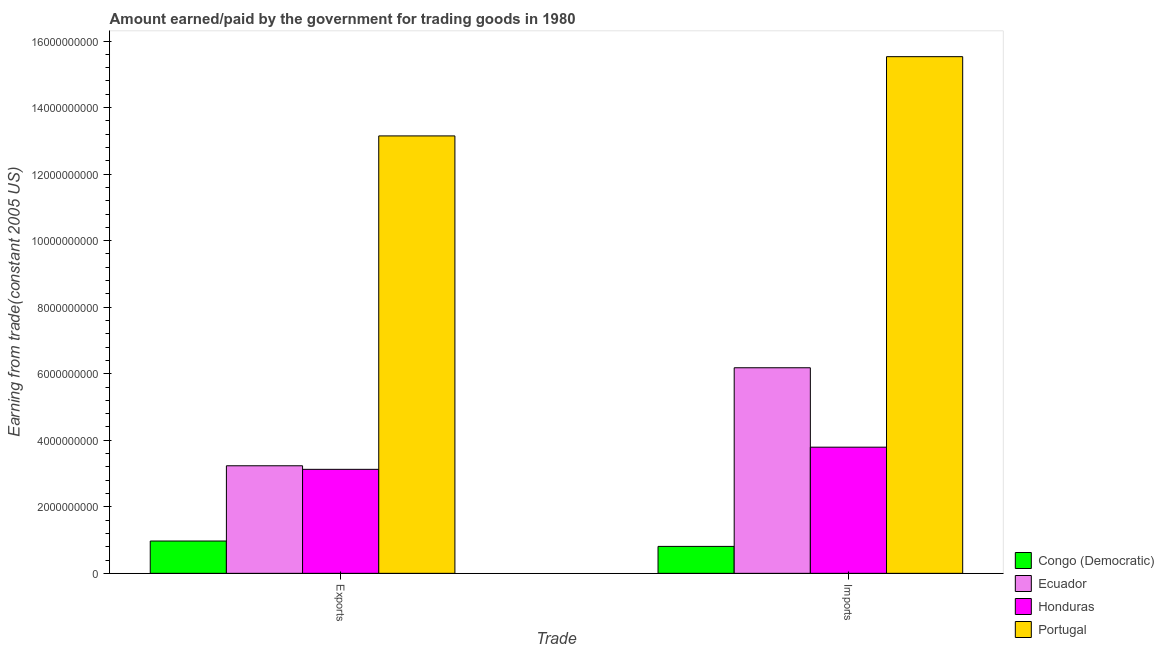How many groups of bars are there?
Offer a terse response. 2. Are the number of bars on each tick of the X-axis equal?
Offer a terse response. Yes. How many bars are there on the 2nd tick from the left?
Offer a very short reply. 4. How many bars are there on the 1st tick from the right?
Offer a terse response. 4. What is the label of the 2nd group of bars from the left?
Your response must be concise. Imports. What is the amount paid for imports in Honduras?
Give a very brief answer. 3.79e+09. Across all countries, what is the maximum amount earned from exports?
Make the answer very short. 1.31e+1. Across all countries, what is the minimum amount earned from exports?
Ensure brevity in your answer.  9.71e+08. In which country was the amount earned from exports minimum?
Your answer should be compact. Congo (Democratic). What is the total amount earned from exports in the graph?
Give a very brief answer. 2.05e+1. What is the difference between the amount paid for imports in Honduras and that in Congo (Democratic)?
Provide a short and direct response. 2.98e+09. What is the difference between the amount earned from exports in Portugal and the amount paid for imports in Honduras?
Provide a short and direct response. 9.36e+09. What is the average amount paid for imports per country?
Provide a succinct answer. 6.58e+09. What is the difference between the amount earned from exports and amount paid for imports in Honduras?
Provide a succinct answer. -6.66e+08. In how many countries, is the amount earned from exports greater than 2800000000 US$?
Your response must be concise. 3. What is the ratio of the amount earned from exports in Congo (Democratic) to that in Honduras?
Offer a very short reply. 0.31. What does the 4th bar from the left in Imports represents?
Offer a very short reply. Portugal. What does the 3rd bar from the right in Exports represents?
Give a very brief answer. Ecuador. Are the values on the major ticks of Y-axis written in scientific E-notation?
Your answer should be very brief. No. Does the graph contain any zero values?
Keep it short and to the point. No. Does the graph contain grids?
Provide a short and direct response. No. How many legend labels are there?
Provide a short and direct response. 4. How are the legend labels stacked?
Provide a short and direct response. Vertical. What is the title of the graph?
Make the answer very short. Amount earned/paid by the government for trading goods in 1980. Does "Jordan" appear as one of the legend labels in the graph?
Provide a short and direct response. No. What is the label or title of the X-axis?
Ensure brevity in your answer.  Trade. What is the label or title of the Y-axis?
Make the answer very short. Earning from trade(constant 2005 US). What is the Earning from trade(constant 2005 US) in Congo (Democratic) in Exports?
Your answer should be compact. 9.71e+08. What is the Earning from trade(constant 2005 US) of Ecuador in Exports?
Provide a short and direct response. 3.23e+09. What is the Earning from trade(constant 2005 US) of Honduras in Exports?
Provide a short and direct response. 3.13e+09. What is the Earning from trade(constant 2005 US) in Portugal in Exports?
Your response must be concise. 1.31e+1. What is the Earning from trade(constant 2005 US) in Congo (Democratic) in Imports?
Offer a terse response. 8.10e+08. What is the Earning from trade(constant 2005 US) of Ecuador in Imports?
Your answer should be very brief. 6.18e+09. What is the Earning from trade(constant 2005 US) in Honduras in Imports?
Offer a very short reply. 3.79e+09. What is the Earning from trade(constant 2005 US) of Portugal in Imports?
Make the answer very short. 1.55e+1. Across all Trade, what is the maximum Earning from trade(constant 2005 US) of Congo (Democratic)?
Give a very brief answer. 9.71e+08. Across all Trade, what is the maximum Earning from trade(constant 2005 US) in Ecuador?
Provide a succinct answer. 6.18e+09. Across all Trade, what is the maximum Earning from trade(constant 2005 US) in Honduras?
Offer a very short reply. 3.79e+09. Across all Trade, what is the maximum Earning from trade(constant 2005 US) of Portugal?
Make the answer very short. 1.55e+1. Across all Trade, what is the minimum Earning from trade(constant 2005 US) of Congo (Democratic)?
Provide a succinct answer. 8.10e+08. Across all Trade, what is the minimum Earning from trade(constant 2005 US) in Ecuador?
Offer a very short reply. 3.23e+09. Across all Trade, what is the minimum Earning from trade(constant 2005 US) in Honduras?
Make the answer very short. 3.13e+09. Across all Trade, what is the minimum Earning from trade(constant 2005 US) in Portugal?
Provide a short and direct response. 1.31e+1. What is the total Earning from trade(constant 2005 US) in Congo (Democratic) in the graph?
Keep it short and to the point. 1.78e+09. What is the total Earning from trade(constant 2005 US) in Ecuador in the graph?
Provide a succinct answer. 9.41e+09. What is the total Earning from trade(constant 2005 US) of Honduras in the graph?
Your response must be concise. 6.92e+09. What is the total Earning from trade(constant 2005 US) of Portugal in the graph?
Your answer should be compact. 2.87e+1. What is the difference between the Earning from trade(constant 2005 US) of Congo (Democratic) in Exports and that in Imports?
Your answer should be very brief. 1.61e+08. What is the difference between the Earning from trade(constant 2005 US) in Ecuador in Exports and that in Imports?
Offer a terse response. -2.95e+09. What is the difference between the Earning from trade(constant 2005 US) in Honduras in Exports and that in Imports?
Keep it short and to the point. -6.66e+08. What is the difference between the Earning from trade(constant 2005 US) in Portugal in Exports and that in Imports?
Ensure brevity in your answer.  -2.38e+09. What is the difference between the Earning from trade(constant 2005 US) of Congo (Democratic) in Exports and the Earning from trade(constant 2005 US) of Ecuador in Imports?
Your answer should be compact. -5.21e+09. What is the difference between the Earning from trade(constant 2005 US) in Congo (Democratic) in Exports and the Earning from trade(constant 2005 US) in Honduras in Imports?
Make the answer very short. -2.82e+09. What is the difference between the Earning from trade(constant 2005 US) in Congo (Democratic) in Exports and the Earning from trade(constant 2005 US) in Portugal in Imports?
Make the answer very short. -1.46e+1. What is the difference between the Earning from trade(constant 2005 US) in Ecuador in Exports and the Earning from trade(constant 2005 US) in Honduras in Imports?
Offer a very short reply. -5.59e+08. What is the difference between the Earning from trade(constant 2005 US) of Ecuador in Exports and the Earning from trade(constant 2005 US) of Portugal in Imports?
Make the answer very short. -1.23e+1. What is the difference between the Earning from trade(constant 2005 US) of Honduras in Exports and the Earning from trade(constant 2005 US) of Portugal in Imports?
Your answer should be very brief. -1.24e+1. What is the average Earning from trade(constant 2005 US) in Congo (Democratic) per Trade?
Offer a very short reply. 8.90e+08. What is the average Earning from trade(constant 2005 US) in Ecuador per Trade?
Provide a succinct answer. 4.71e+09. What is the average Earning from trade(constant 2005 US) of Honduras per Trade?
Ensure brevity in your answer.  3.46e+09. What is the average Earning from trade(constant 2005 US) in Portugal per Trade?
Your answer should be compact. 1.43e+1. What is the difference between the Earning from trade(constant 2005 US) in Congo (Democratic) and Earning from trade(constant 2005 US) in Ecuador in Exports?
Provide a short and direct response. -2.26e+09. What is the difference between the Earning from trade(constant 2005 US) of Congo (Democratic) and Earning from trade(constant 2005 US) of Honduras in Exports?
Provide a succinct answer. -2.15e+09. What is the difference between the Earning from trade(constant 2005 US) of Congo (Democratic) and Earning from trade(constant 2005 US) of Portugal in Exports?
Offer a very short reply. -1.22e+1. What is the difference between the Earning from trade(constant 2005 US) of Ecuador and Earning from trade(constant 2005 US) of Honduras in Exports?
Offer a very short reply. 1.07e+08. What is the difference between the Earning from trade(constant 2005 US) of Ecuador and Earning from trade(constant 2005 US) of Portugal in Exports?
Ensure brevity in your answer.  -9.91e+09. What is the difference between the Earning from trade(constant 2005 US) of Honduras and Earning from trade(constant 2005 US) of Portugal in Exports?
Offer a very short reply. -1.00e+1. What is the difference between the Earning from trade(constant 2005 US) in Congo (Democratic) and Earning from trade(constant 2005 US) in Ecuador in Imports?
Provide a succinct answer. -5.37e+09. What is the difference between the Earning from trade(constant 2005 US) in Congo (Democratic) and Earning from trade(constant 2005 US) in Honduras in Imports?
Your answer should be very brief. -2.98e+09. What is the difference between the Earning from trade(constant 2005 US) of Congo (Democratic) and Earning from trade(constant 2005 US) of Portugal in Imports?
Keep it short and to the point. -1.47e+1. What is the difference between the Earning from trade(constant 2005 US) of Ecuador and Earning from trade(constant 2005 US) of Honduras in Imports?
Offer a very short reply. 2.39e+09. What is the difference between the Earning from trade(constant 2005 US) in Ecuador and Earning from trade(constant 2005 US) in Portugal in Imports?
Provide a short and direct response. -9.35e+09. What is the difference between the Earning from trade(constant 2005 US) of Honduras and Earning from trade(constant 2005 US) of Portugal in Imports?
Keep it short and to the point. -1.17e+1. What is the ratio of the Earning from trade(constant 2005 US) in Congo (Democratic) in Exports to that in Imports?
Your response must be concise. 1.2. What is the ratio of the Earning from trade(constant 2005 US) in Ecuador in Exports to that in Imports?
Your response must be concise. 0.52. What is the ratio of the Earning from trade(constant 2005 US) of Honduras in Exports to that in Imports?
Keep it short and to the point. 0.82. What is the ratio of the Earning from trade(constant 2005 US) in Portugal in Exports to that in Imports?
Your answer should be very brief. 0.85. What is the difference between the highest and the second highest Earning from trade(constant 2005 US) of Congo (Democratic)?
Your answer should be very brief. 1.61e+08. What is the difference between the highest and the second highest Earning from trade(constant 2005 US) of Ecuador?
Your answer should be compact. 2.95e+09. What is the difference between the highest and the second highest Earning from trade(constant 2005 US) in Honduras?
Provide a succinct answer. 6.66e+08. What is the difference between the highest and the second highest Earning from trade(constant 2005 US) of Portugal?
Make the answer very short. 2.38e+09. What is the difference between the highest and the lowest Earning from trade(constant 2005 US) in Congo (Democratic)?
Your answer should be compact. 1.61e+08. What is the difference between the highest and the lowest Earning from trade(constant 2005 US) in Ecuador?
Offer a very short reply. 2.95e+09. What is the difference between the highest and the lowest Earning from trade(constant 2005 US) of Honduras?
Your response must be concise. 6.66e+08. What is the difference between the highest and the lowest Earning from trade(constant 2005 US) in Portugal?
Give a very brief answer. 2.38e+09. 